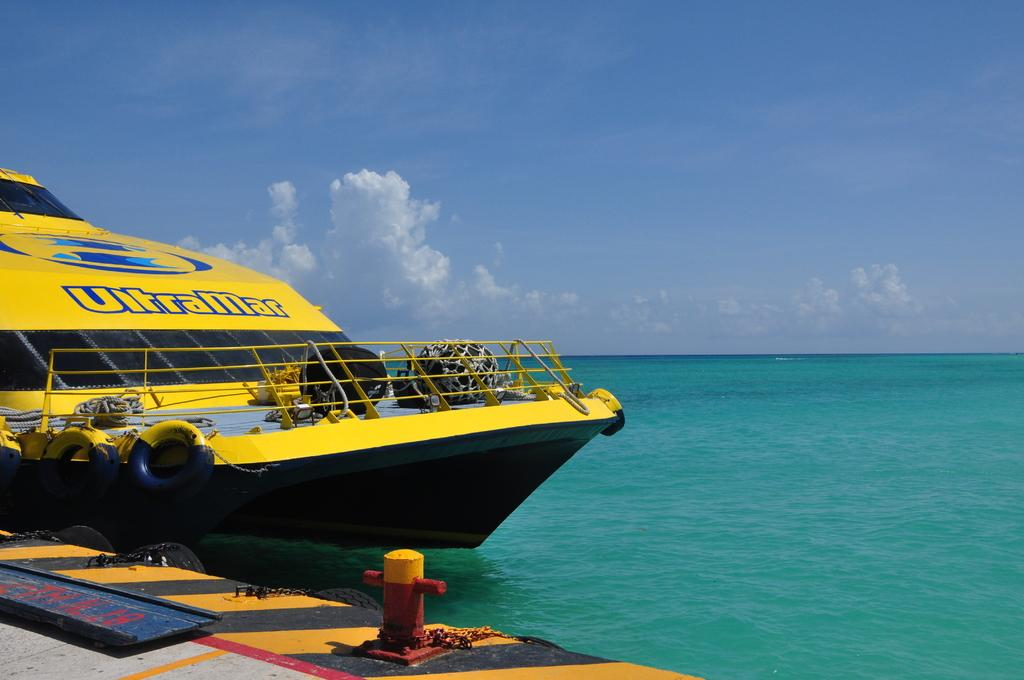<image>
Write a terse but informative summary of the picture. A boat called the UltraMar is docked at a pier. 